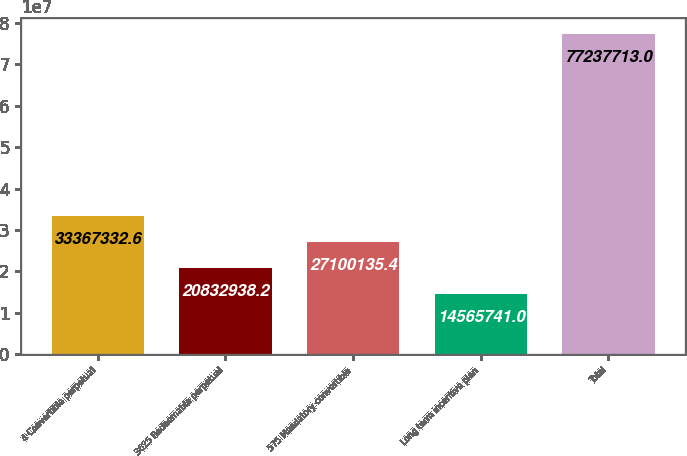Convert chart. <chart><loc_0><loc_0><loc_500><loc_500><bar_chart><fcel>4 Convertible perpetual<fcel>3625 Redeemable perpetual<fcel>575 Mandatory convertible<fcel>Long term incentive plan<fcel>Total<nl><fcel>3.33673e+07<fcel>2.08329e+07<fcel>2.71001e+07<fcel>1.45657e+07<fcel>7.72377e+07<nl></chart> 